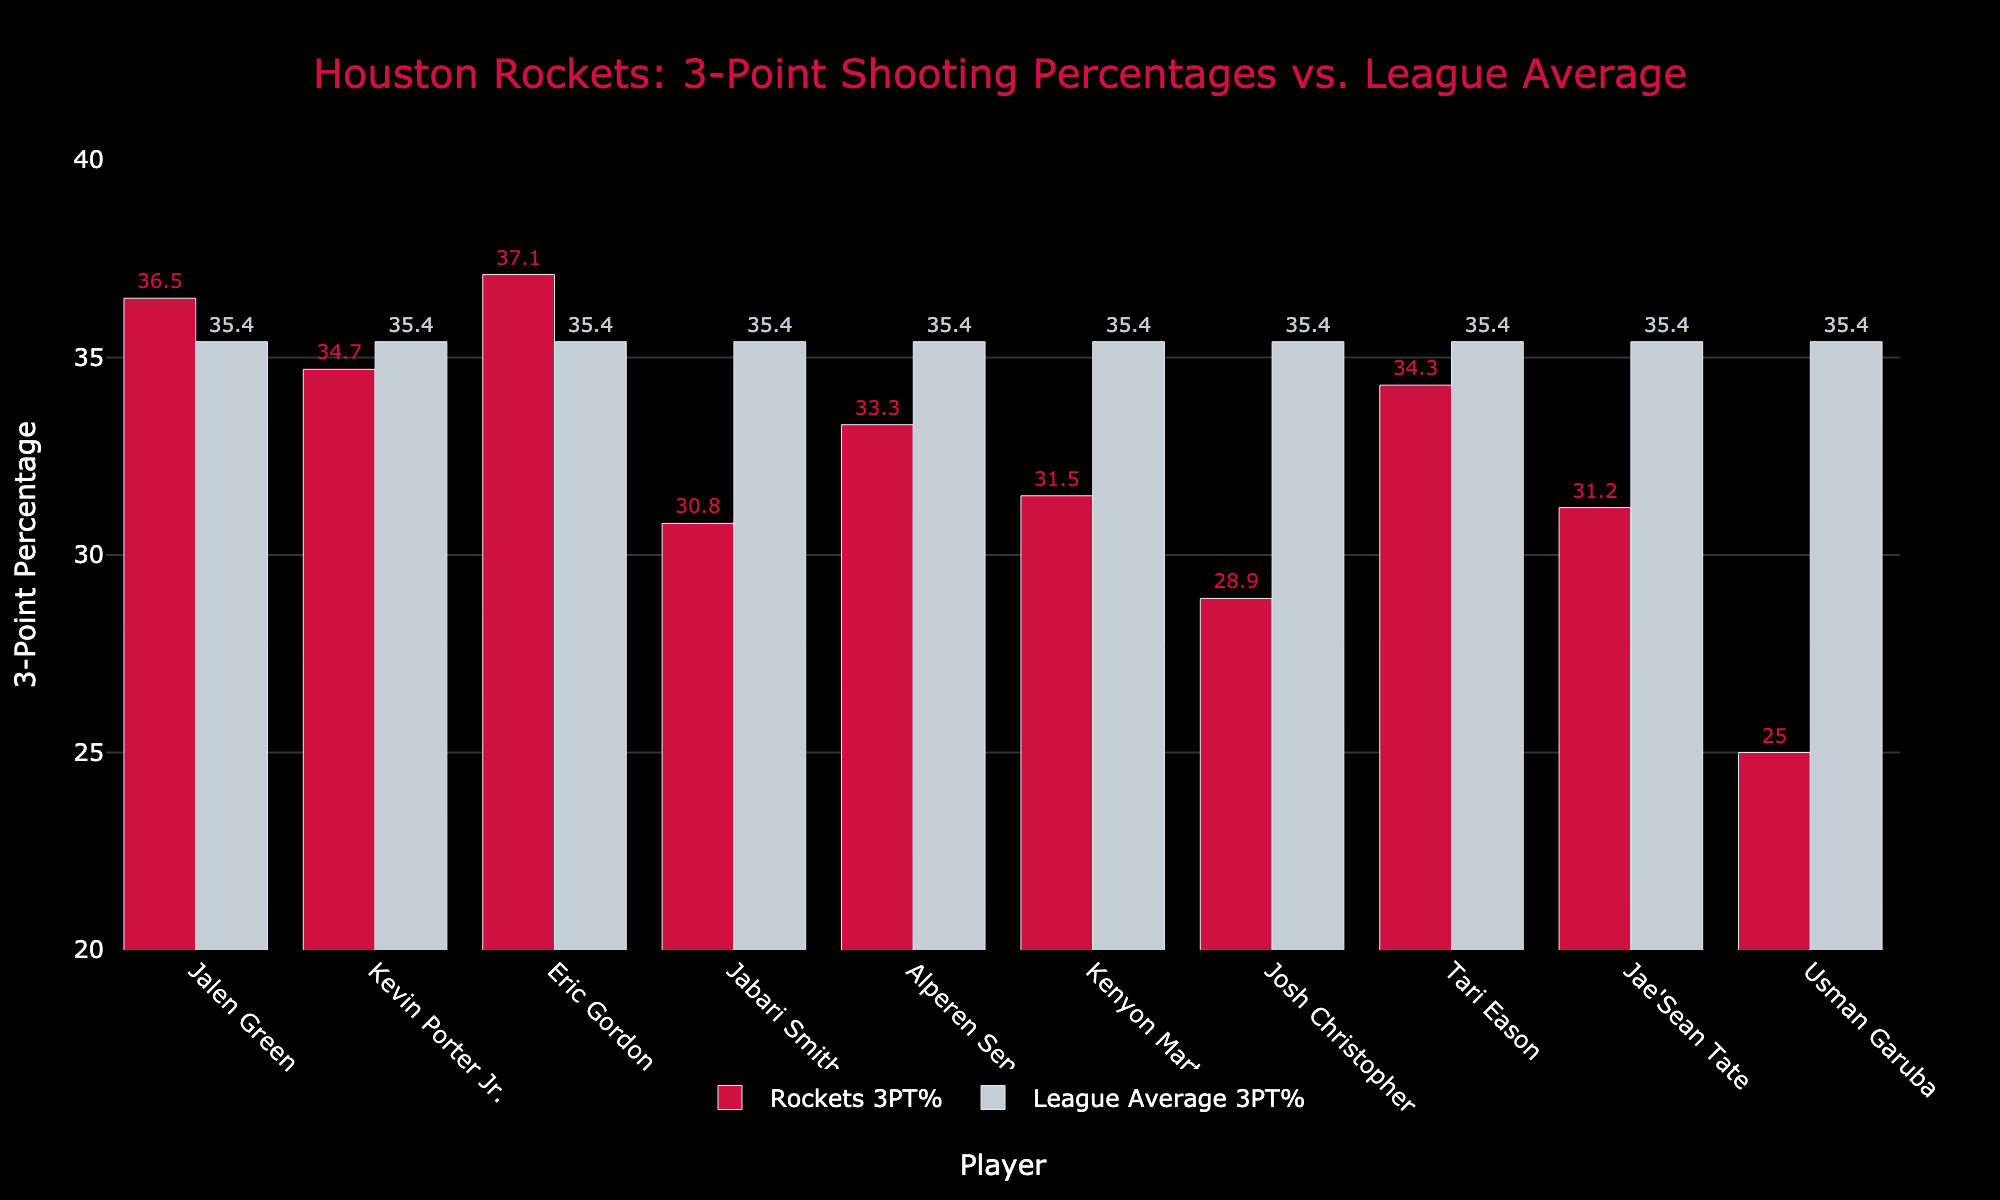Which Rockets player has the highest 3-point shooting percentage? The highest bar in the "Rockets 3PT%" category visually represents the player with the highest percentage. Eric Gordon's bar is the tallest in the Rockets 3PT% group at 37.1%.
Answer: Eric Gordon Is Jalen Green's 3-point percentage above or below the league average? Compare the height of Jalen Green's bar in the Rockets 3PT% group with that of the league average bar. Jalen Green's bar at 36.5% is higher than the league average bar at 35.4%.
Answer: Above Which player has the biggest gap between their 3PT% and the league average? Calculate the differences between each player's Rockets 3PT% and the league average (35.4%). The largest negative difference occurs for Usman Garuba: 35.4% - 25.0% = 10.4%.
Answer: Usman Garuba How many players have a 3PT% below the league average? Count the players whose bar heights in the Rockets 3PT% category are lower than the league average bar at 35.4%. Seven players (Kevin Porter Jr., Jabari Smith Jr., Alperen Sengun, Kenyon Martin Jr., Josh Christopher, Jae'Sean Tate, Usman Garuba) have 3PT% below the league average.
Answer: Seven Compare the 3PT% of Kevin Porter Jr. with Tari Eason. Who has a higher percentage? Compare the heights of Kevin Porter Jr.'s and Tari Eason's bars in the Rockets 3PT% category. Tari Eason's bar (34.3%) is slightly below Kevin Porter Jr.'s bar (34.7%).
Answer: Kevin Porter Jr Is there any player whose 3PT% is exactly equal to the league average? Visually inspect if any player's bar in the Rockets 3PT% category coincides exactly with the league average bar. None of the players have a 3PT% that matches the league average of 35.4%.
Answer: No What is the average 3PT% for Rockets players shown in the chart? Sum up all Rockets players' 3PT% and divide by the number of players: (36.5 + 34.7 + 37.1 + 30.8 + 33.3 + 31.5 + 28.9 + 34.3 + 31.2 + 25.0) / 10 = 323.3 / 10 = 32.33%.
Answer: 32.33 By how much does Eric Gordon's 3PT% exceed Jabari Smith Jr.'s 3PT%? Subtract Jabari Smith Jr.'s 3PT% from Eric Gordon's 3PT%: 37.1% - 30.8% = 6.3%.
Answer: 6.3% Which players' 3PT% are less than Jae'Sean Tate's 3PT%? Identify bars in the Rockets 3PT% category that are shorter than Jae'Sean Tate's bar (31.2%). Only Usman Garuba has a shorter bar at 25.0%.
Answer: Usman Garuba 